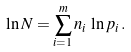<formula> <loc_0><loc_0><loc_500><loc_500>\ln N = \sum _ { i = 1 } ^ { m } n _ { i } \, \ln p _ { i } \, .</formula> 